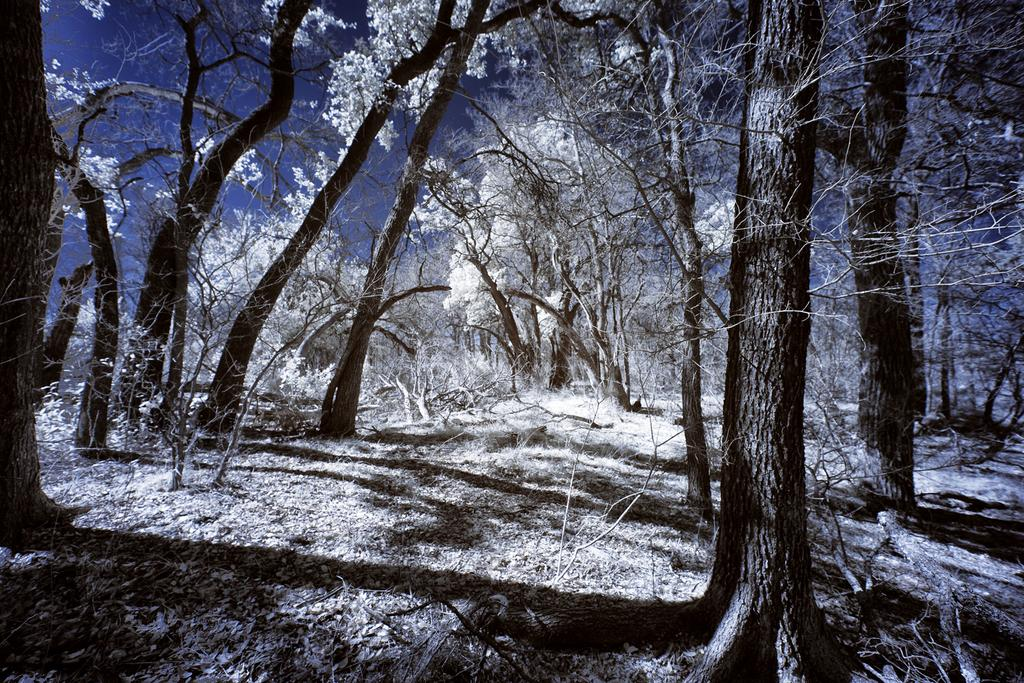What type of vegetation is present in the image? There are trees with snow in the image. What part of the natural environment is visible in the image? The sky is visible in the image. What time of day is depicted in the image? The sky is at night in the image. What type of church can be seen in the image? There is no church present in the image; it features trees with snow and a night sky. What is the root of the tree doing in the image? There is no root visible in the image, as it focuses on the trees with snow and the night sky. 